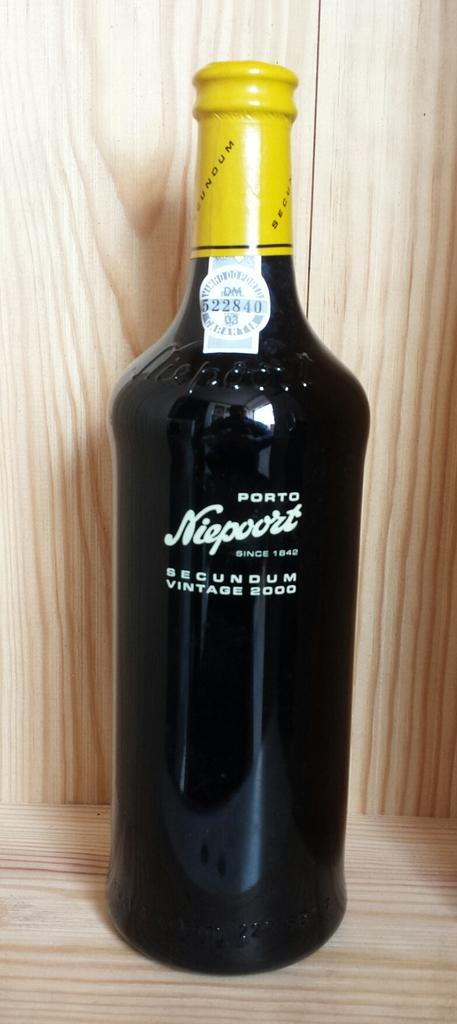<image>
Summarize the visual content of the image. A black bottle of Porto Niepoort with a yellow seal on the cap. 